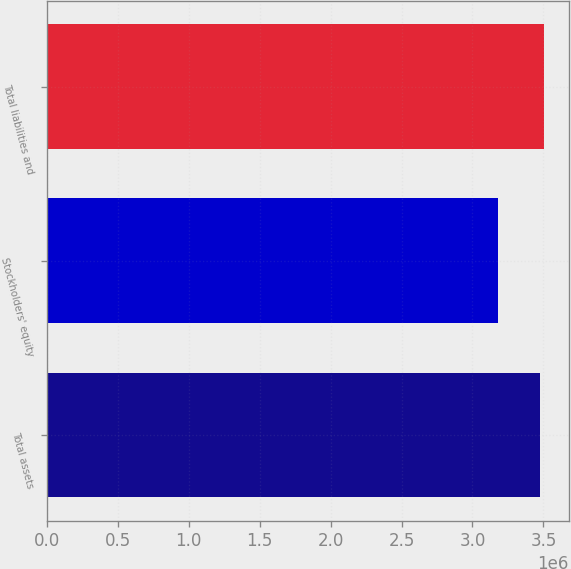<chart> <loc_0><loc_0><loc_500><loc_500><bar_chart><fcel>Total assets<fcel>Stockholders' equity<fcel>Total liabilities and<nl><fcel>3.4738e+06<fcel>3.18277e+06<fcel>3.5029e+06<nl></chart> 